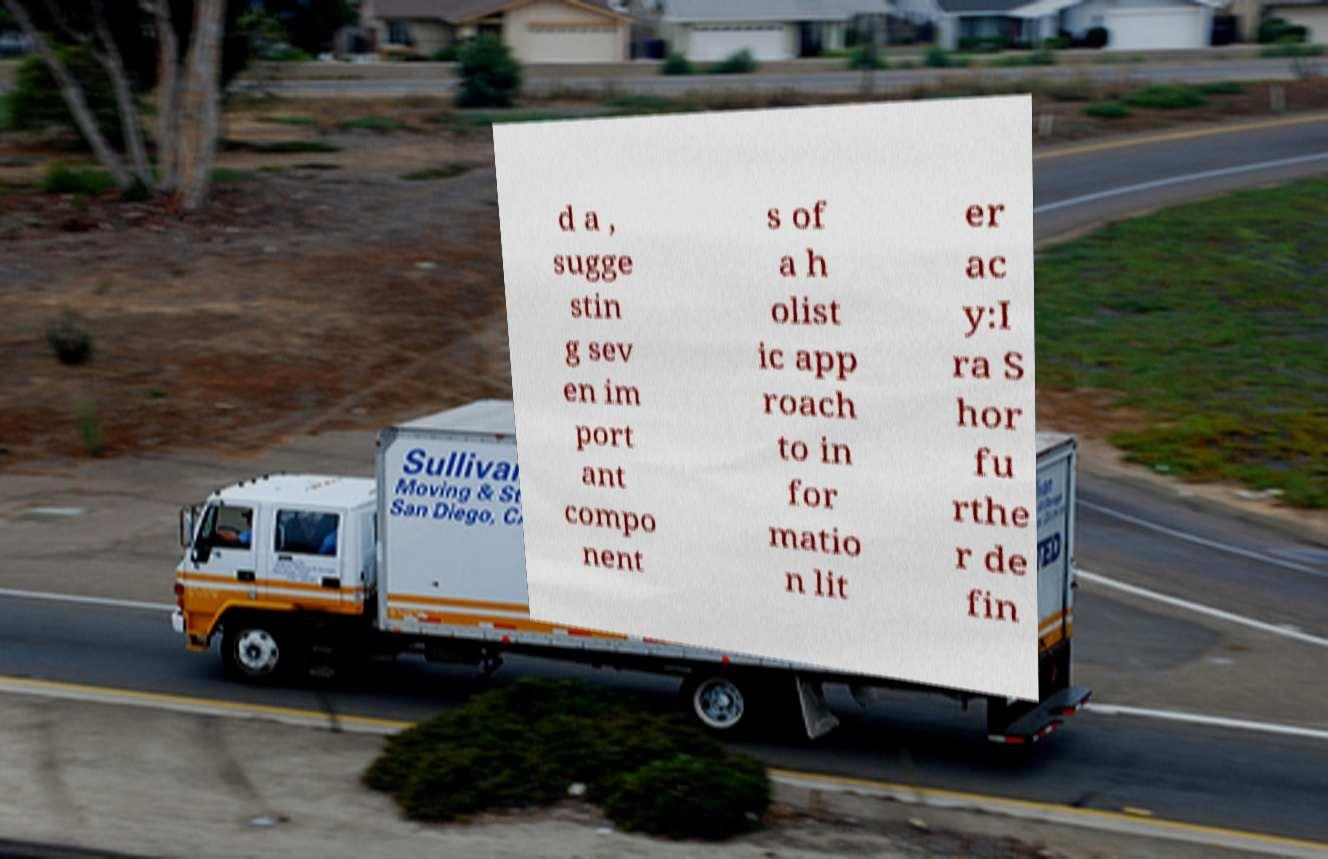I need the written content from this picture converted into text. Can you do that? d a , sugge stin g sev en im port ant compo nent s of a h olist ic app roach to in for matio n lit er ac y:I ra S hor fu rthe r de fin 